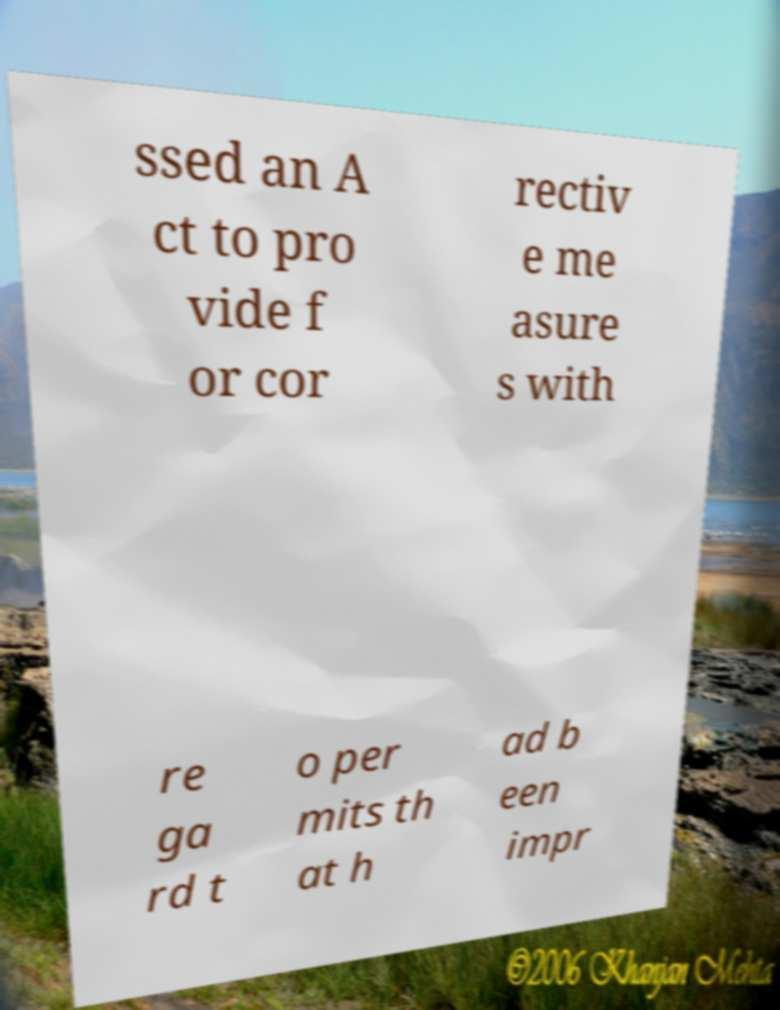Can you read and provide the text displayed in the image?This photo seems to have some interesting text. Can you extract and type it out for me? ssed an A ct to pro vide f or cor rectiv e me asure s with re ga rd t o per mits th at h ad b een impr 